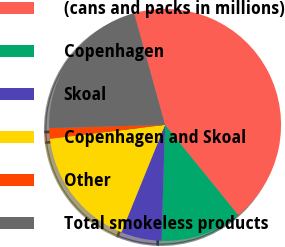Convert chart to OTSL. <chart><loc_0><loc_0><loc_500><loc_500><pie_chart><fcel>(cans and packs in millions)<fcel>Copenhagen<fcel>Skoal<fcel>Copenhagen and Skoal<fcel>Other<fcel>Total smokeless products<nl><fcel>43.47%<fcel>11.32%<fcel>5.66%<fcel>16.95%<fcel>1.46%<fcel>21.15%<nl></chart> 